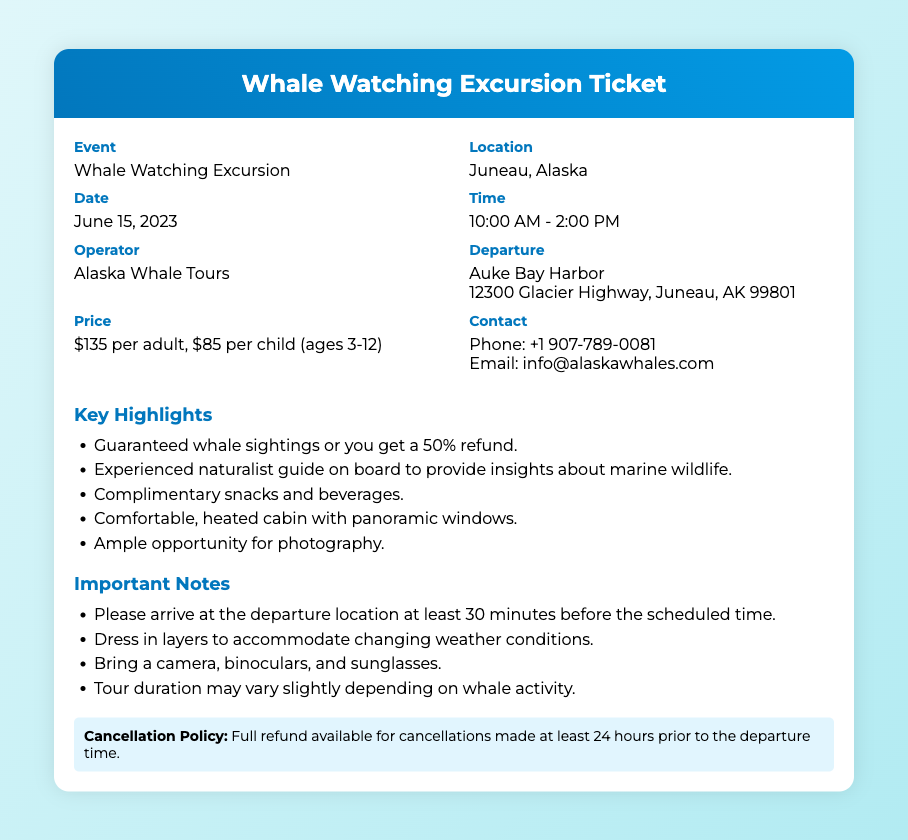What is the event name? The event name is clearly stated in the document under "Event."
Answer: Whale Watching Excursion Where is the excursion located? The location is specified next to "Location" in the document.
Answer: Juneau, Alaska What is the date of the whale watching excursion? The date is mentioned under "Date" in the ticket.
Answer: June 15, 2023 What is the price for an adult ticket? The price for an adult ticket is outlined under "Price."
Answer: $135 per adult Who operates the whale watching excursion? The operator's name is listed under "Operator."
Answer: Alaska Whale Tours What should participants bring with them? The important notes section lists what participants should bring.
Answer: Camera, binoculars, and sunglasses How long before departure should guests arrive? The note explicitly states the arrival time before departure.
Answer: 30 minutes What is the cancellation policy? The cancellation policy is highlighted near the end of the document.
Answer: Full refund available for cancellations made at least 24 hours prior What amenities are included in the excursion? The highlights section mentions included amenities.
Answer: Complimentary snacks and beverages What is the duration of the tour? The notes mention that the tour duration is subject to variation based on activity.
Answer: May vary slightly depending on whale activity 